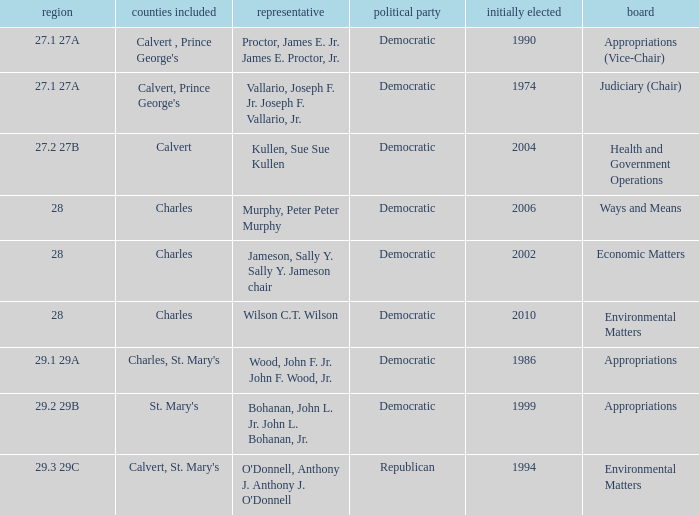Which was the district that had first elected greater than 2006 and is democratic? 28.0. 